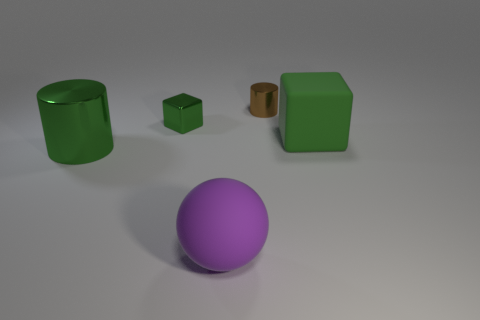Add 3 large shiny objects. How many objects exist? 8 Subtract all cubes. How many objects are left? 3 Add 5 metal things. How many metal things exist? 8 Subtract 0 green spheres. How many objects are left? 5 Subtract all big brown rubber cubes. Subtract all green blocks. How many objects are left? 3 Add 5 large shiny things. How many large shiny things are left? 6 